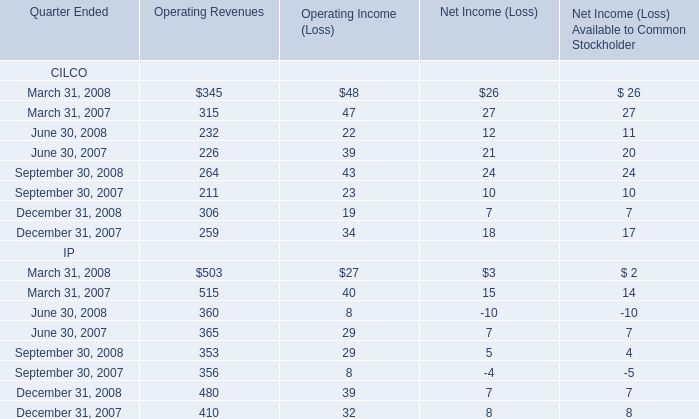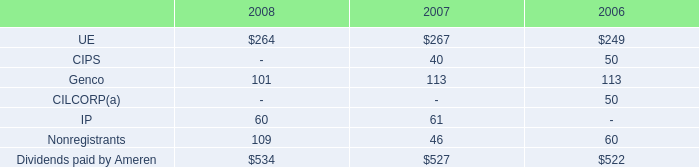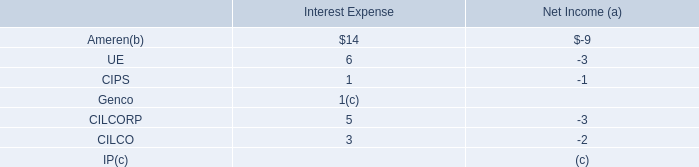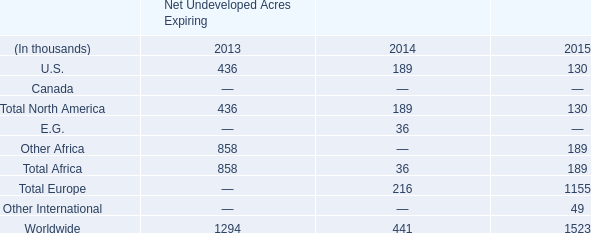What's the current increasing rate of Operating revenues of CILCO? 
Computations: (((((345 + 232) + 264) + 306) - (((315 + 226) + 211) + 259)) / (((315 + 226) + 211) + 259))
Answer: 0.13452. 